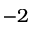Convert formula to latex. <formula><loc_0><loc_0><loc_500><loc_500>- 2</formula> 